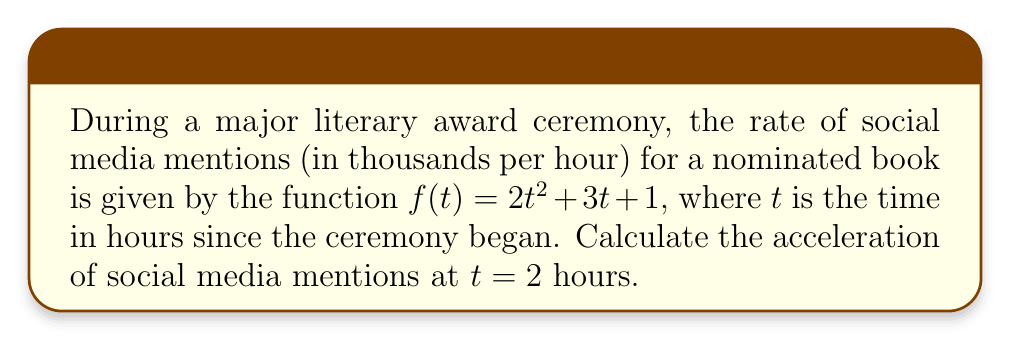Help me with this question. To find the acceleration of social media mentions, we need to calculate the second derivative of the given function $f(t)$.

Step 1: Find the first derivative (velocity of mentions)
The first derivative represents the rate of change of mentions:
$$f'(t) = \frac{d}{dt}(2t^2 + 3t + 1) = 4t + 3$$

Step 2: Find the second derivative (acceleration of mentions)
The second derivative represents the rate of change of the velocity:
$$f''(t) = \frac{d}{dt}(4t + 3) = 4$$

Step 3: Evaluate the second derivative at $t = 2$
Since the second derivative is a constant, the acceleration is the same at all times, including $t = 2$:
$$f''(2) = 4$$

Therefore, the acceleration of social media mentions is 4 thousand mentions per hour squared at $t = 2$ hours (and at all other times during the ceremony).
Answer: $4$ thousand mentions/hour² 